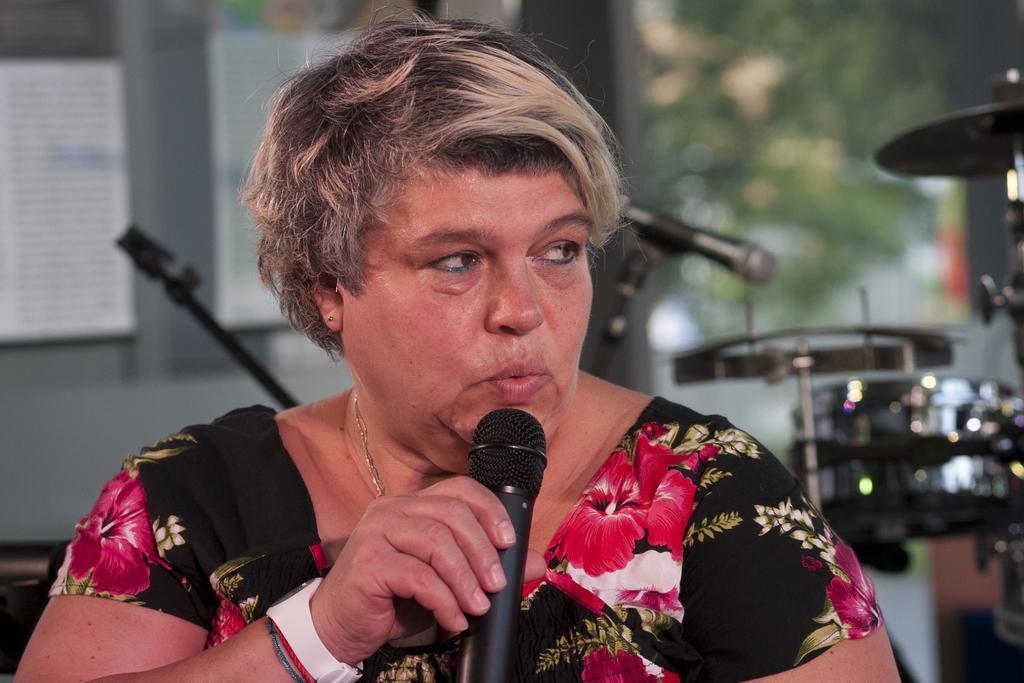Can you describe this image briefly? In this image, There is a woman holding a microphone which is in black color and she is speaking in the microphone, In the background there are some music instruments and there is a green color tree. 